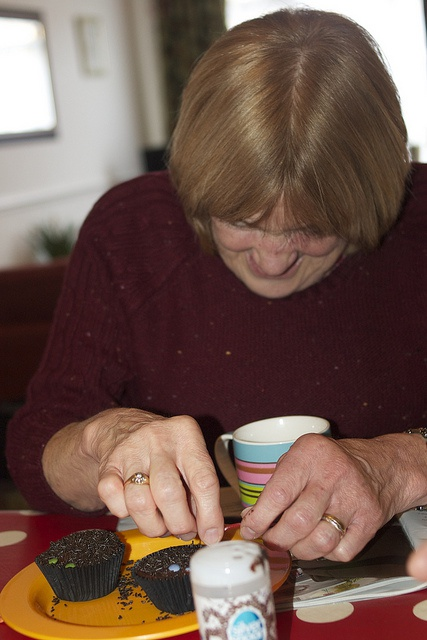Describe the objects in this image and their specific colors. I can see people in darkgray, black, gray, and maroon tones, dining table in darkgray, maroon, black, and gray tones, tv in darkgray, white, gray, and lightgray tones, cup in darkgray, lightgray, and maroon tones, and cake in darkgray, black, gray, and darkgreen tones in this image. 